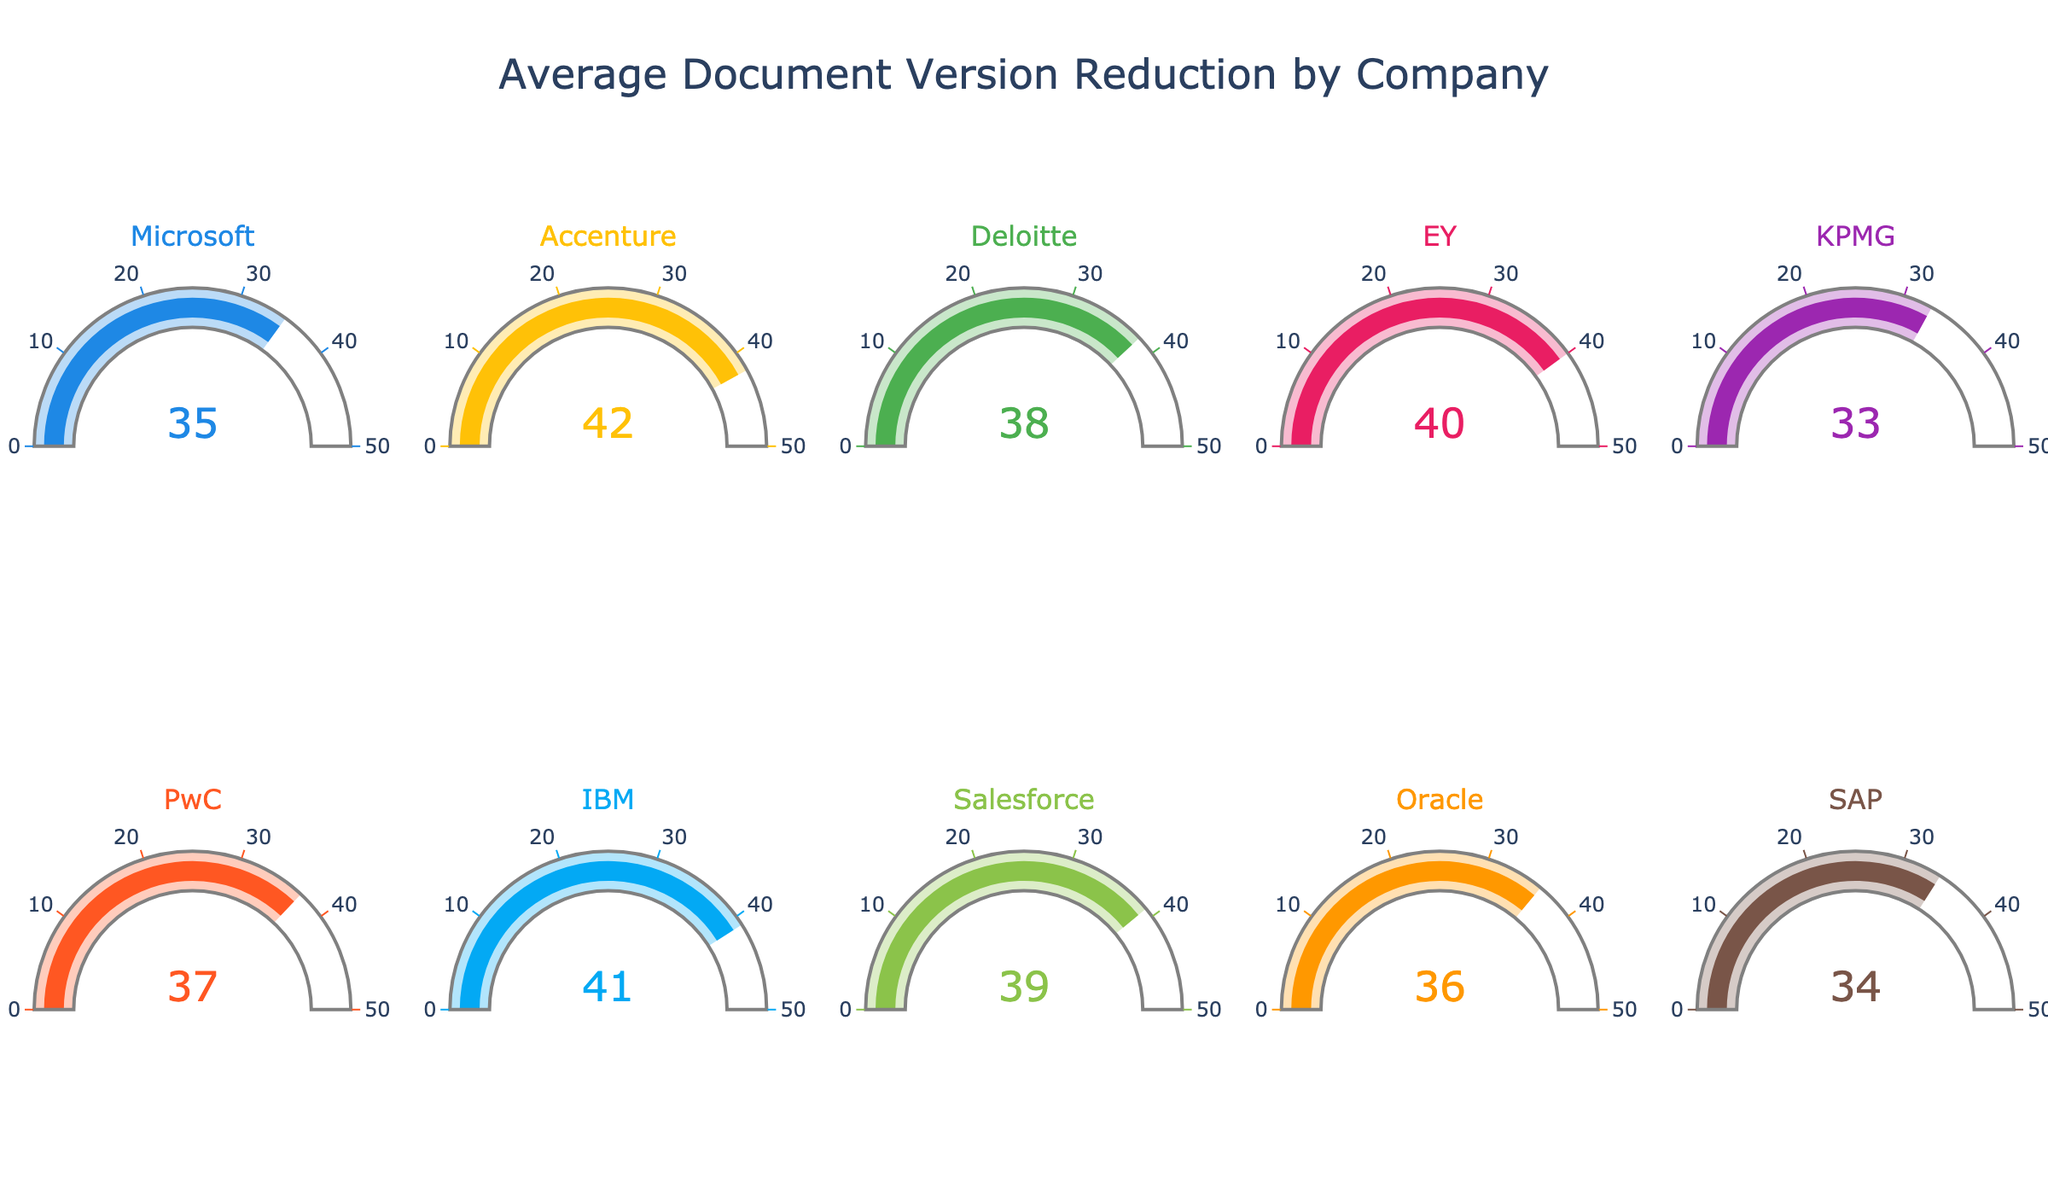What's the title of the figure? The title is prominently displayed at the top center of the figure, with a larger font size. It reads "Average Document Version Reduction by Company."
Answer: Average Document Version Reduction by Company How many companies are represented in the figure? Each gauge chart shows the document version reduction for one company, and there are 10 gauges in the figure.
Answer: 10 Which company achieved the highest average document version reduction? By observing the numbers on each gauge chart, the highest reduction is 42, which corresponds to Accenture.
Answer: Accenture What is the average document version reduction across all companies? First, sum the reductions: 35 + 42 + 38 + 40 + 33 + 37 + 41 + 39 + 36 + 34 = 375. Then, divide by the number of companies: 375 / 10 = 37.5.
Answer: 37.5 What's the difference in document version reduction between Microsoft and Oracle? Microsoft has a reduction of 35, and Oracle has a reduction of 36. The difference is 36 - 35.
Answer: 1 Which two companies have the closest document version reductions? Comparing the values, SAP (34) and KPMG (33) have a difference of 1, the smallest difference among all.
Answer: SAP and KPMG What is the range of the document version reductions displayed? The range is calculated as the difference between the maximum and minimum reductions: 42 (Accenture) - 33 (KPMG).
Answer: 9 How many companies have a document version reduction of 40 or higher? By visual inspection, the companies are Accenture (42), EY (40), IBM (41), and Deloitte (38). Therefore, three companies: Accenture (42), EY (40), and IBM (41).
Answer: 3 Which companies achieved a reduction greater than 38? By inspecting the values, Accenture (42), EY (40), IBM (41), and Salesforce (39) have reductions greater than 38.
Answer: Accenture, EY, IBM, Salesforce What is the median document version reduction in the dataset? To find the median, list the reductions in order: 33, 34, 35, 36, 37, 38, 39, 40, 41, 42. The median is the average of the 5th and 6th values: (37 + 38) / 2 = 37.5.
Answer: 37.5 